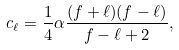Convert formula to latex. <formula><loc_0><loc_0><loc_500><loc_500>c _ { \ell } = \frac { 1 } { 4 } \alpha \frac { ( f + \ell ) ( f - \ell ) } { f - \ell + 2 } ,</formula> 